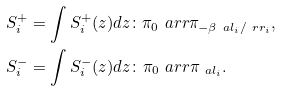<formula> <loc_0><loc_0><loc_500><loc_500>S ^ { + } _ { i } & = \int S ^ { + } _ { i } ( z ) d z \colon \pi _ { 0 } \ a r r \pi _ { - \beta \ a l _ { i } / \ r r _ { i } } , \\ S ^ { - } _ { i } & = \int S ^ { - } _ { i } ( z ) d z \colon \pi _ { 0 } \ a r r \pi _ { \ a l _ { i } } .</formula> 